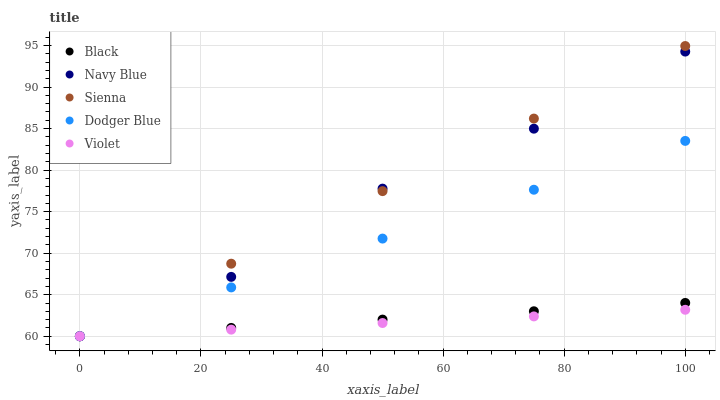Does Violet have the minimum area under the curve?
Answer yes or no. Yes. Does Sienna have the maximum area under the curve?
Answer yes or no. Yes. Does Navy Blue have the minimum area under the curve?
Answer yes or no. No. Does Navy Blue have the maximum area under the curve?
Answer yes or no. No. Is Sienna the smoothest?
Answer yes or no. Yes. Is Navy Blue the roughest?
Answer yes or no. Yes. Is Black the smoothest?
Answer yes or no. No. Is Black the roughest?
Answer yes or no. No. Does Sienna have the lowest value?
Answer yes or no. Yes. Does Sienna have the highest value?
Answer yes or no. Yes. Does Navy Blue have the highest value?
Answer yes or no. No. Does Violet intersect Black?
Answer yes or no. Yes. Is Violet less than Black?
Answer yes or no. No. Is Violet greater than Black?
Answer yes or no. No. 